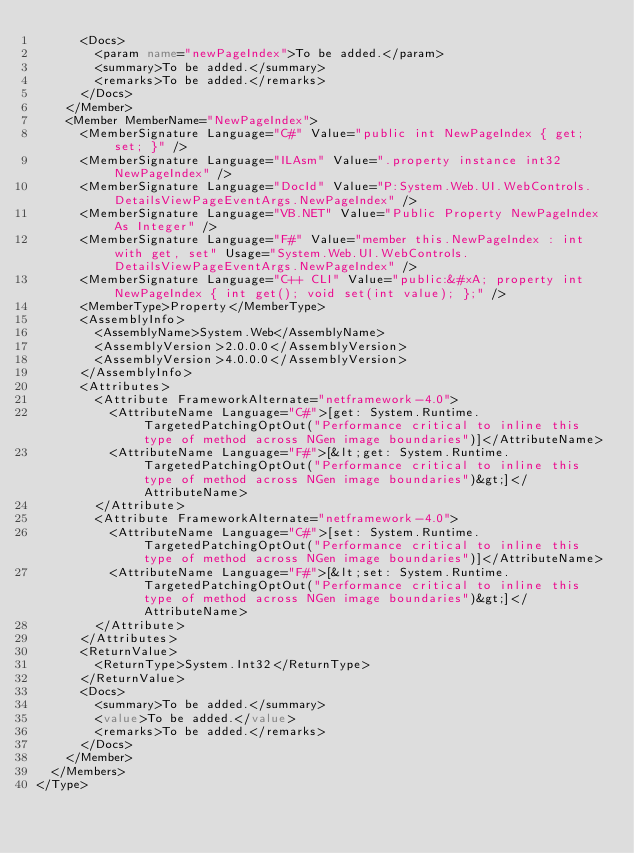Convert code to text. <code><loc_0><loc_0><loc_500><loc_500><_XML_>      <Docs>
        <param name="newPageIndex">To be added.</param>
        <summary>To be added.</summary>
        <remarks>To be added.</remarks>
      </Docs>
    </Member>
    <Member MemberName="NewPageIndex">
      <MemberSignature Language="C#" Value="public int NewPageIndex { get; set; }" />
      <MemberSignature Language="ILAsm" Value=".property instance int32 NewPageIndex" />
      <MemberSignature Language="DocId" Value="P:System.Web.UI.WebControls.DetailsViewPageEventArgs.NewPageIndex" />
      <MemberSignature Language="VB.NET" Value="Public Property NewPageIndex As Integer" />
      <MemberSignature Language="F#" Value="member this.NewPageIndex : int with get, set" Usage="System.Web.UI.WebControls.DetailsViewPageEventArgs.NewPageIndex" />
      <MemberSignature Language="C++ CLI" Value="public:&#xA; property int NewPageIndex { int get(); void set(int value); };" />
      <MemberType>Property</MemberType>
      <AssemblyInfo>
        <AssemblyName>System.Web</AssemblyName>
        <AssemblyVersion>2.0.0.0</AssemblyVersion>
        <AssemblyVersion>4.0.0.0</AssemblyVersion>
      </AssemblyInfo>
      <Attributes>
        <Attribute FrameworkAlternate="netframework-4.0">
          <AttributeName Language="C#">[get: System.Runtime.TargetedPatchingOptOut("Performance critical to inline this type of method across NGen image boundaries")]</AttributeName>
          <AttributeName Language="F#">[&lt;get: System.Runtime.TargetedPatchingOptOut("Performance critical to inline this type of method across NGen image boundaries")&gt;]</AttributeName>
        </Attribute>
        <Attribute FrameworkAlternate="netframework-4.0">
          <AttributeName Language="C#">[set: System.Runtime.TargetedPatchingOptOut("Performance critical to inline this type of method across NGen image boundaries")]</AttributeName>
          <AttributeName Language="F#">[&lt;set: System.Runtime.TargetedPatchingOptOut("Performance critical to inline this type of method across NGen image boundaries")&gt;]</AttributeName>
        </Attribute>
      </Attributes>
      <ReturnValue>
        <ReturnType>System.Int32</ReturnType>
      </ReturnValue>
      <Docs>
        <summary>To be added.</summary>
        <value>To be added.</value>
        <remarks>To be added.</remarks>
      </Docs>
    </Member>
  </Members>
</Type>
</code> 